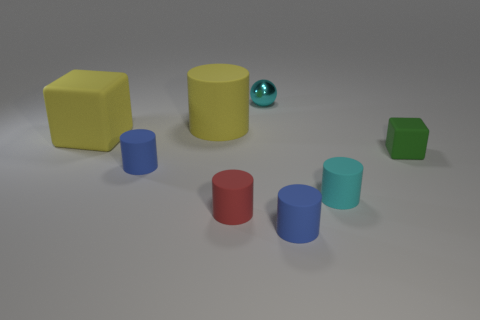Are there fewer tiny green matte objects than rubber things?
Keep it short and to the point. Yes. There is a cylinder that is behind the rubber block to the left of the red rubber cylinder; what size is it?
Give a very brief answer. Large. What is the shape of the green matte object that is on the right side of the large yellow object behind the rubber block that is behind the green matte cube?
Ensure brevity in your answer.  Cube. What color is the big cube that is the same material as the red thing?
Your response must be concise. Yellow. What is the color of the matte cylinder behind the blue rubber cylinder that is behind the tiny cyan thing that is in front of the green matte cube?
Keep it short and to the point. Yellow. How many cubes are either tiny yellow matte things or tiny cyan things?
Keep it short and to the point. 0. There is a thing that is the same color as the metallic ball; what material is it?
Provide a succinct answer. Rubber. Do the large rubber block and the rubber thing that is behind the large yellow cube have the same color?
Provide a short and direct response. Yes. The tiny metal object is what color?
Keep it short and to the point. Cyan. How many objects are either cyan balls or small cyan matte cylinders?
Your answer should be compact. 2. 